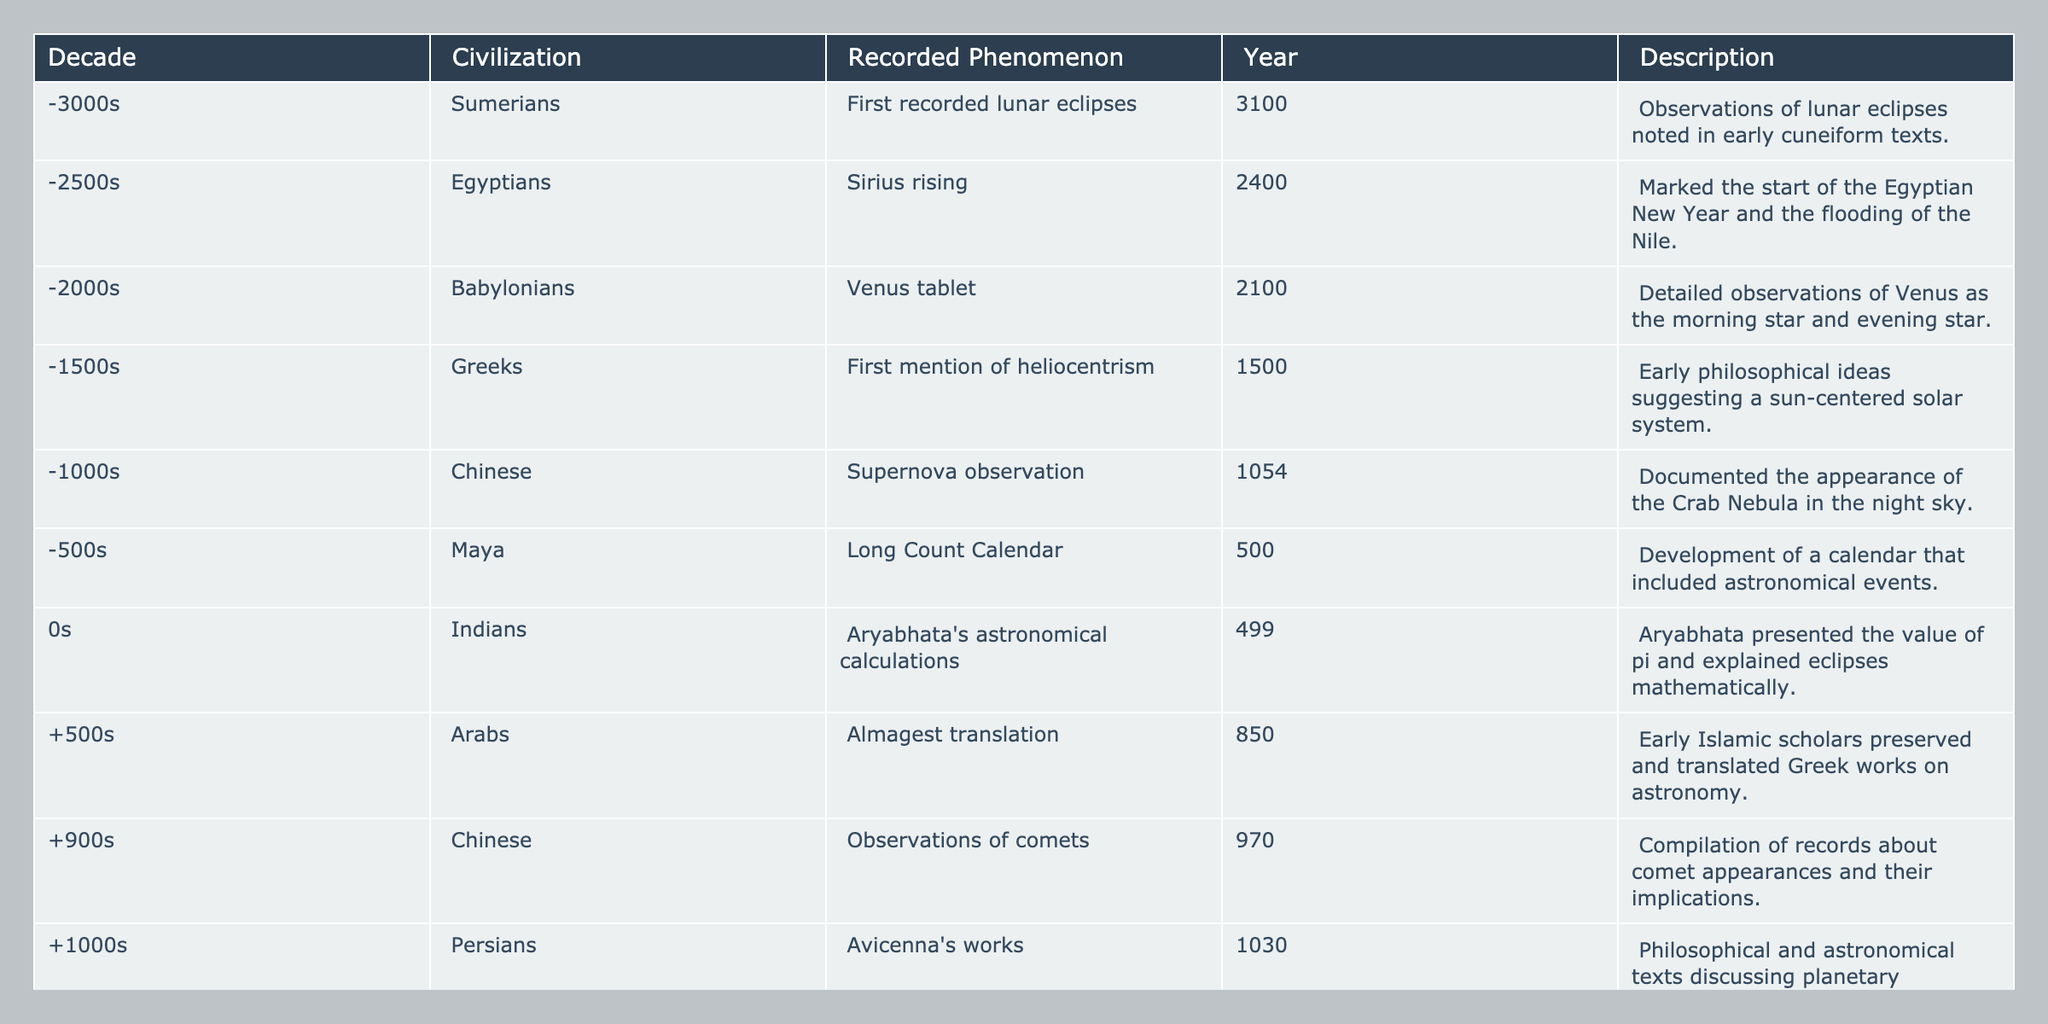What civilization recorded the first lunar eclipses? The table lists the Sumerians as the civilization that recorded the first lunar eclipses in the year 3100.
Answer: Sumerians In which decade did the Egyptians record Sirius rising? The table indicates that the Egyptians recorded Sirius rising in the 2400s, specifically around 2400.
Answer: 2400s How many civilizations recorded astronomical phenomena in the first millennium BCE? The table shows that there are five civilizations that recorded phenomena from the 3000s to the 0s which sums up to a total of five civilizations.
Answer: Five civilizations Was the concept of heliocentrism introduced before or after the year 0? According to the table, the first mention of heliocentrism by the Greeks occurred in the year 1500, which is after the year 0.
Answer: After What is the average year of recorded astronomical phenomena from the Babylonians and Persians? The Babylonians recorded phenomena in 2100 and the Persians in 1030. Summing these gives 2100 + 1030 = 3130, and dividing by 2 gives an average of 1565.
Answer: 1565 Which phenomenon was recorded by the Maya, and in what year? The table states that the Maya recorded the Long Count Calendar in the year 500.
Answer: Long Count Calendar, 500 Did any civilization observe supernova events before the year 0? According to the table, the Chinese observed a supernova in 1054, which is indeed before the year 0.
Answer: No Which recorded phenomenon is associated with Aryabhata? The table states that Aryabhata presented his astronomical calculations in the year 499, focusing on eclipses and pi.
Answer: Aryabhata's astronomical calculations How many years separate the recorded phenomenon of lunar eclipses from the introduction of the Gregorian calendar? The lunar eclipses were recorded in 3100, while the Gregorian calendar was introduced in 1582. The difference is 3100 - 1582 = 1518 years.
Answer: 1518 years What significant astronomical concept was introduced by early Greeks in the 1500s? The table mentions that the Greeks introduced the first mention of heliocentrism in the year 1500.
Answer: Heliocentrism 